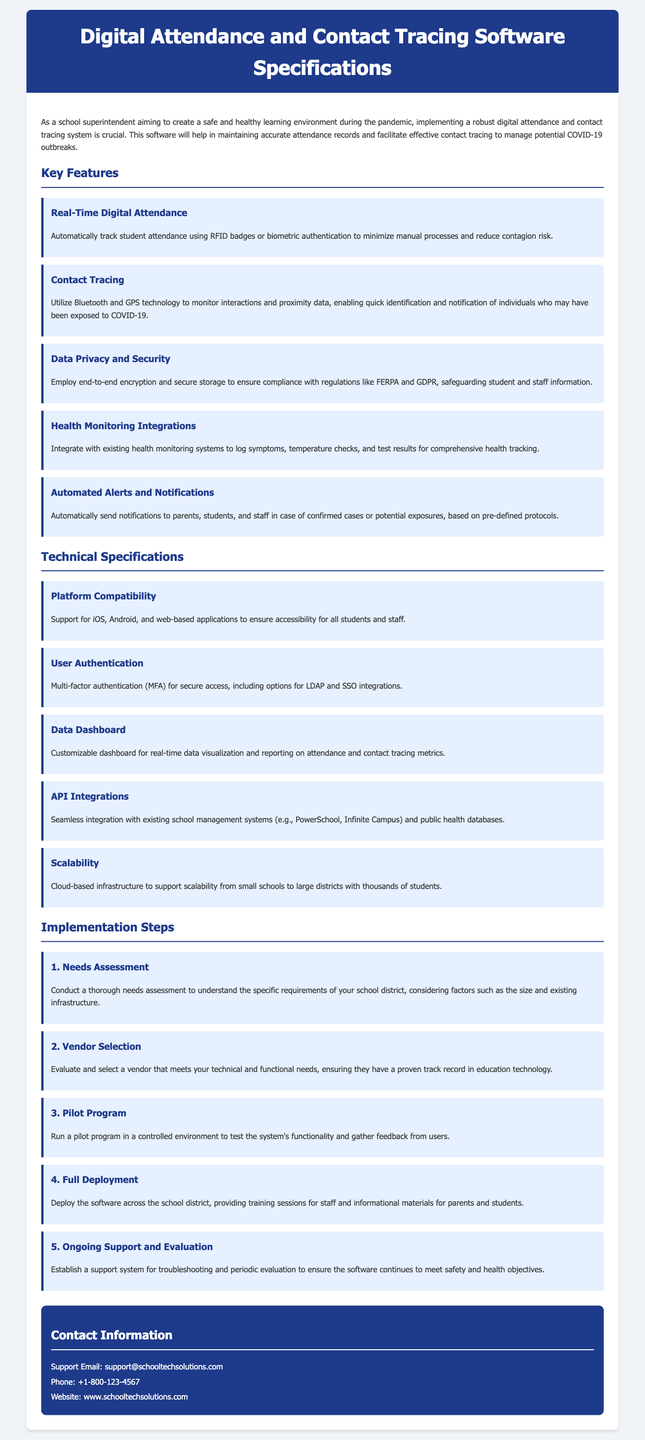What are the key features of the software? The key features include Real-Time Digital Attendance, Contact Tracing, Data Privacy and Security, Health Monitoring Integrations, and Automated Alerts and Notifications.
Answer: Real-Time Digital Attendance, Contact Tracing, Data Privacy and Security, Health Monitoring Integrations, Automated Alerts and Notifications What does the contact tracing feature utilize? The contact tracing feature utilizes Bluetooth and GPS technology to monitor interactions.
Answer: Bluetooth and GPS technology How many implementation steps are outlined in the document? The document outlines five implementation steps for the software deployment.
Answer: Five What is the support email provided in the contact information? The support email listed for contact is support@schooltechsolutions.com.
Answer: support@schooltechsolutions.com What technology is employed for user authentication? Multi-factor authentication (MFA) is employed for secure access as part of user authentication.
Answer: Multi-factor authentication (MFA) What is the significance of data encryption mentioned in the document? Data encryption is significant for ensuring compliance with regulations like FERPA and GDPR.
Answer: Compliance with regulations like FERPA and GDPR What type of infrastructure is recommended for scalability? The document recommends a cloud-based infrastructure for scalability.
Answer: Cloud-based infrastructure What is mentioned as a component for health monitoring integrations? The document mentions logging symptoms, temperature checks, and test results as components for health monitoring integrations.
Answer: Logging symptoms, temperature checks, and test results 